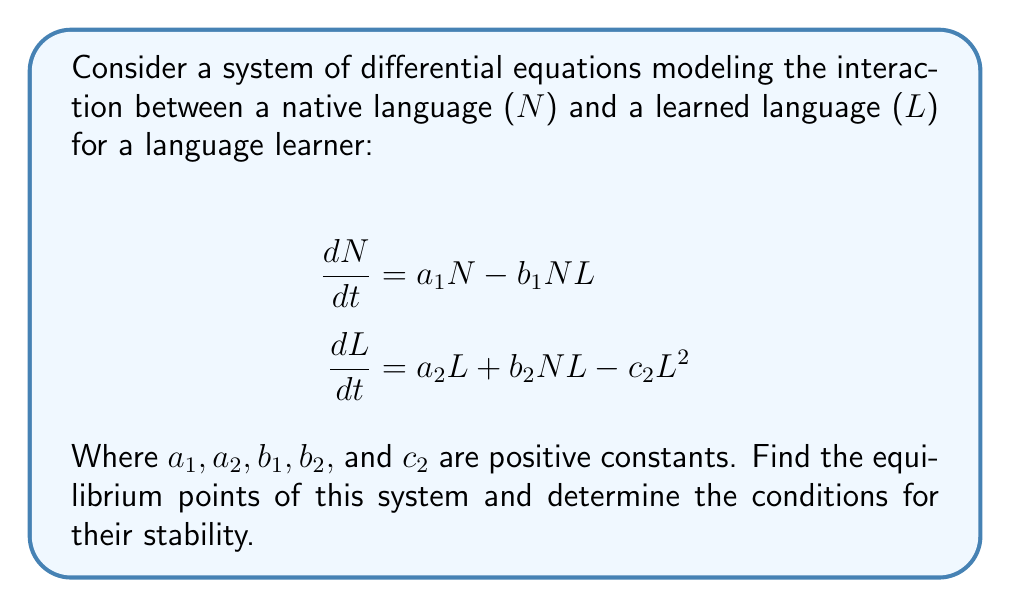What is the answer to this math problem? To find the equilibrium points, we set both equations equal to zero and solve for N and L:

1) $\frac{dN}{dt} = 0$:
   $a_1N - b_1NL = 0$
   $N(a_1 - b_1L) = 0$
   So, either $N = 0$ or $L = \frac{a_1}{b_1}$

2) $\frac{dL}{dt} = 0$:
   $a_2L + b_2NL - c_2L^2 = 0$
   $L(a_2 + b_2N - c_2L) = 0$
   So, either $L = 0$ or $N = \frac{c_2L - a_2}{b_2}$

From these, we can identify three equilibrium points:

a) $(0, 0)$: Both native and learned languages are extinct.
b) $(0, \frac{a_2}{c_2})$: Native language is extinct, learned language persists.
c) $(\frac{a_1c_2 - a_1a_2}{b_1a_2}, \frac{a_1}{b_1})$: Both languages coexist.

To determine stability, we need to evaluate the Jacobian matrix at each equilibrium point:

$$J = \begin{bmatrix}
a_1 - b_1L & -b_1N \\
b_2L & a_2 + b_2N - 2c_2L
\end{bmatrix}$$

For point (a): $J_{(0,0)} = \begin{bmatrix}
a_1 & 0 \\
0 & a_2
\end{bmatrix}$
Eigenvalues: $\lambda_1 = a_1, \lambda_2 = a_2$
This point is unstable as both eigenvalues are positive.

For point (b): $J_{(0,\frac{a_2}{c_2})} = \begin{bmatrix}
a_1 - b_1\frac{a_2}{c_2} & 0 \\
b_2\frac{a_2}{c_2} & -a_2
\end{bmatrix}$
Eigenvalues: $\lambda_1 = a_1 - b_1\frac{a_2}{c_2}, \lambda_2 = -a_2$
This point is stable if $a_1 < b_1\frac{a_2}{c_2}$

For point (c): The stability analysis is more complex and depends on the specific values of the parameters.
Answer: The system has three equilibrium points:
1) $(0, 0)$ - unstable
2) $(0, \frac{a_2}{c_2})$ - stable if $a_1 < b_1\frac{a_2}{c_2}$
3) $(\frac{a_1c_2 - a_1a_2}{b_1a_2}, \frac{a_1}{b_1})$ - stability depends on parameter values

The conditions for stability of the second equilibrium point (where only the learned language persists) is $a_1 < b_1\frac{a_2}{c_2}$. 